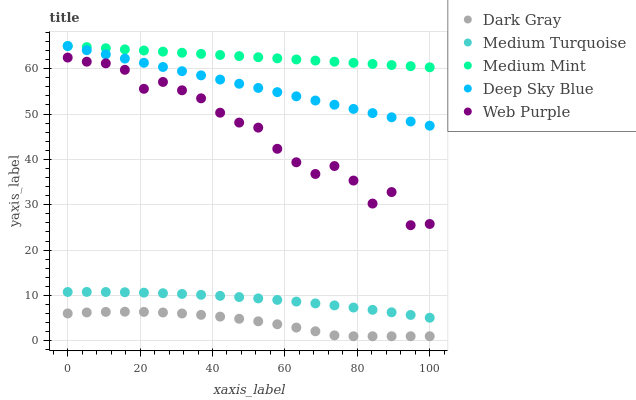Does Dark Gray have the minimum area under the curve?
Answer yes or no. Yes. Does Medium Mint have the maximum area under the curve?
Answer yes or no. Yes. Does Web Purple have the minimum area under the curve?
Answer yes or no. No. Does Web Purple have the maximum area under the curve?
Answer yes or no. No. Is Deep Sky Blue the smoothest?
Answer yes or no. Yes. Is Web Purple the roughest?
Answer yes or no. Yes. Is Medium Mint the smoothest?
Answer yes or no. No. Is Medium Mint the roughest?
Answer yes or no. No. Does Dark Gray have the lowest value?
Answer yes or no. Yes. Does Web Purple have the lowest value?
Answer yes or no. No. Does Deep Sky Blue have the highest value?
Answer yes or no. Yes. Does Web Purple have the highest value?
Answer yes or no. No. Is Medium Turquoise less than Medium Mint?
Answer yes or no. Yes. Is Deep Sky Blue greater than Web Purple?
Answer yes or no. Yes. Does Medium Mint intersect Deep Sky Blue?
Answer yes or no. Yes. Is Medium Mint less than Deep Sky Blue?
Answer yes or no. No. Is Medium Mint greater than Deep Sky Blue?
Answer yes or no. No. Does Medium Turquoise intersect Medium Mint?
Answer yes or no. No. 